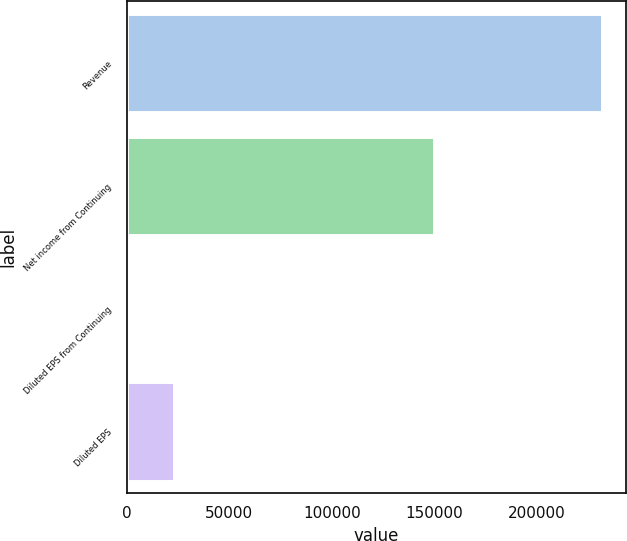<chart> <loc_0><loc_0><loc_500><loc_500><bar_chart><fcel>Revenue<fcel>Net income from Continuing<fcel>Diluted EPS from Continuing<fcel>Diluted EPS<nl><fcel>231817<fcel>149669<fcel>0.46<fcel>23182.1<nl></chart> 